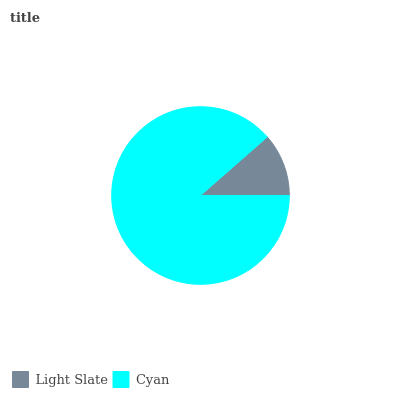Is Light Slate the minimum?
Answer yes or no. Yes. Is Cyan the maximum?
Answer yes or no. Yes. Is Cyan the minimum?
Answer yes or no. No. Is Cyan greater than Light Slate?
Answer yes or no. Yes. Is Light Slate less than Cyan?
Answer yes or no. Yes. Is Light Slate greater than Cyan?
Answer yes or no. No. Is Cyan less than Light Slate?
Answer yes or no. No. Is Cyan the high median?
Answer yes or no. Yes. Is Light Slate the low median?
Answer yes or no. Yes. Is Light Slate the high median?
Answer yes or no. No. Is Cyan the low median?
Answer yes or no. No. 